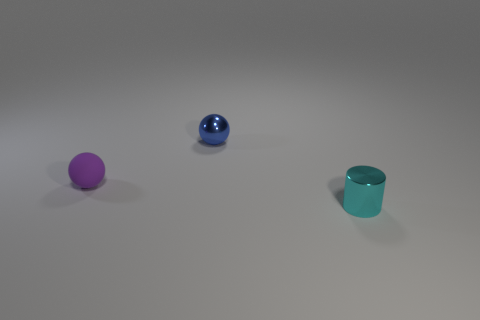What is the shape of the purple matte object?
Provide a short and direct response. Sphere. There is a thing that is left of the object behind the purple object; what is its size?
Provide a succinct answer. Small. How many objects are big gray shiny cylinders or blue spheres?
Provide a succinct answer. 1. Is the shape of the tiny cyan thing the same as the small blue object?
Provide a short and direct response. No. Is there a small cylinder made of the same material as the purple ball?
Your response must be concise. No. Are there any purple matte balls behind the metallic thing that is in front of the blue shiny ball?
Give a very brief answer. Yes. There is a ball that is on the right side of the purple thing; does it have the same size as the cyan metallic object?
Offer a terse response. Yes. How many big objects are either yellow matte cubes or cyan things?
Ensure brevity in your answer.  0. There is a matte thing; how many metal spheres are behind it?
Ensure brevity in your answer.  1. What is the shape of the thing that is behind the cyan shiny cylinder and right of the purple sphere?
Your answer should be compact. Sphere. 